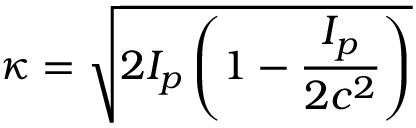<formula> <loc_0><loc_0><loc_500><loc_500>\kappa = \sqrt { 2 I _ { p } \left ( 1 - \frac { I _ { p } } { 2 c ^ { 2 } } \right ) }</formula> 